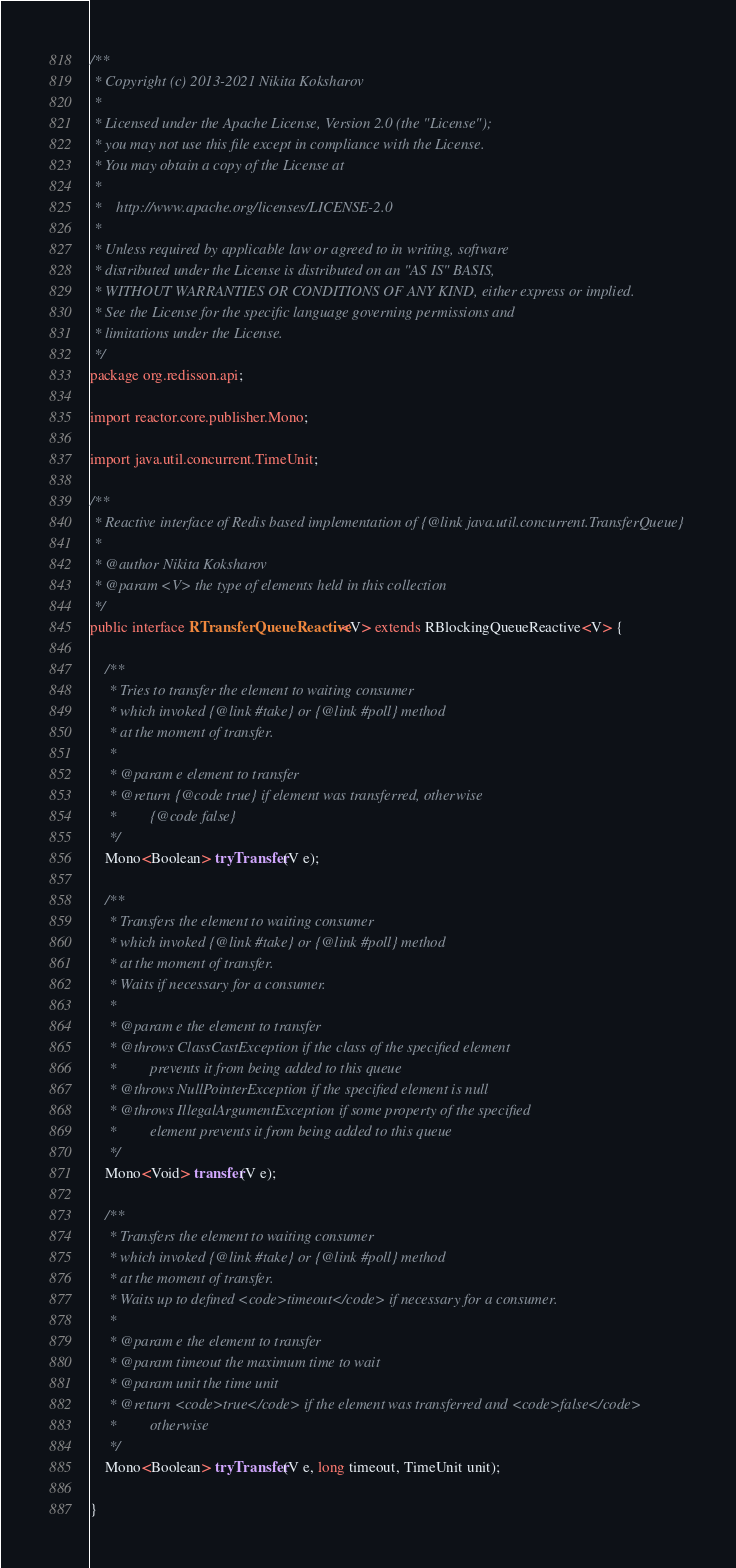Convert code to text. <code><loc_0><loc_0><loc_500><loc_500><_Java_>/**
 * Copyright (c) 2013-2021 Nikita Koksharov
 *
 * Licensed under the Apache License, Version 2.0 (the "License");
 * you may not use this file except in compliance with the License.
 * You may obtain a copy of the License at
 *
 *    http://www.apache.org/licenses/LICENSE-2.0
 *
 * Unless required by applicable law or agreed to in writing, software
 * distributed under the License is distributed on an "AS IS" BASIS,
 * WITHOUT WARRANTIES OR CONDITIONS OF ANY KIND, either express or implied.
 * See the License for the specific language governing permissions and
 * limitations under the License.
 */
package org.redisson.api;

import reactor.core.publisher.Mono;

import java.util.concurrent.TimeUnit;

/**
 * Reactive interface of Redis based implementation of {@link java.util.concurrent.TransferQueue}
 *
 * @author Nikita Koksharov
 * @param <V> the type of elements held in this collection
 */
public interface RTransferQueueReactive<V> extends RBlockingQueueReactive<V> {

    /**
     * Tries to transfer the element to waiting consumer
     * which invoked {@link #take} or {@link #poll} method
     * at the moment of transfer.
     *
     * @param e element to transfer
     * @return {@code true} if element was transferred, otherwise
     *         {@code false}
     */
    Mono<Boolean> tryTransfer(V e);

    /**
     * Transfers the element to waiting consumer
     * which invoked {@link #take} or {@link #poll} method
     * at the moment of transfer.
     * Waits if necessary for a consumer.
     *
     * @param e the element to transfer
     * @throws ClassCastException if the class of the specified element
     *         prevents it from being added to this queue
     * @throws NullPointerException if the specified element is null
     * @throws IllegalArgumentException if some property of the specified
     *         element prevents it from being added to this queue
     */
    Mono<Void> transfer(V e);

    /**
     * Transfers the element to waiting consumer
     * which invoked {@link #take} or {@link #poll} method
     * at the moment of transfer.
     * Waits up to defined <code>timeout</code> if necessary for a consumer.
     *
     * @param e the element to transfer
     * @param timeout the maximum time to wait
     * @param unit the time unit
     * @return <code>true</code> if the element was transferred and <code>false</code>
     *         otherwise
     */
    Mono<Boolean> tryTransfer(V e, long timeout, TimeUnit unit);

}
</code> 